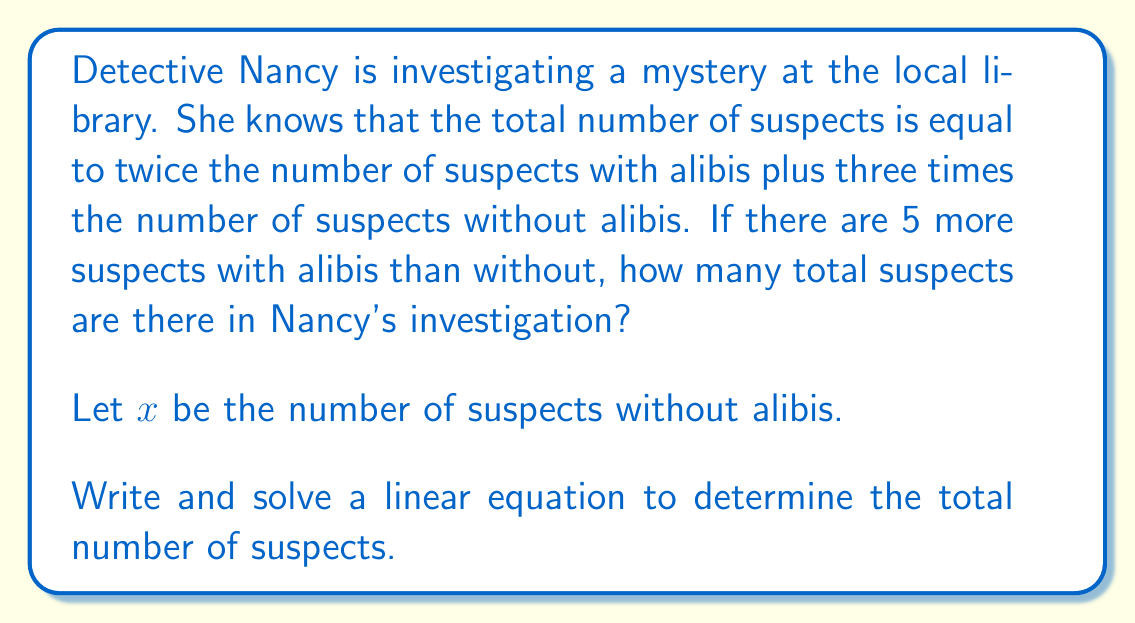Solve this math problem. Let's approach this step-by-step:

1) Let $x$ be the number of suspects without alibis.
   Then, $x+5$ is the number of suspects with alibis.

2) We can write the equation:
   Total suspects $= 2(\text{suspects with alibis}) + 3(\text{suspects without alibis})$

3) Translating this into a linear equation:
   $$\text{Total} = 2(x+5) + 3x$$

4) Simplify the right side:
   $$\text{Total} = 2x + 10 + 3x = 5x + 10$$

5) We don't know the total yet, so let's call it $T$:
   $$T = 5x + 10$$

6) Now, we need to find $x$. We can do this by using the information that there are 5 more suspects with alibis than without:
   $$(x+5) - x = 5$$
   $$5 = 5$$ (This confirms our setup is correct)

7) Now that we know $x = x$, we can substitute this back into our equation for $T$:
   $$T = 5x + 10$$

8) To find $x$, we can use the fact that $x+5$ is the number of suspects with alibis:
   $$x + (x+5) = T$$
   $$2x + 5 = 5x + 10$$

9) Solve this equation:
   $$2x + 5 = 5x + 10$$
   $$-3x = 5$$
   $$x = -\frac{5}{3}$$

10) Since $x$ represents people, it must be a positive integer. The nearest positive integer to $-\frac{5}{3}$ is 2.

11) If $x = 2$, then $x+5 = 7$

12) We can verify: $2 + 7 = 9$ total suspects, and $2(7) + 3(2) = 14 + 6 = 20$

Therefore, there are 9 total suspects in Nancy's investigation.
Answer: 9 suspects 